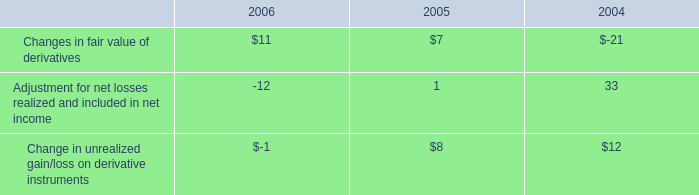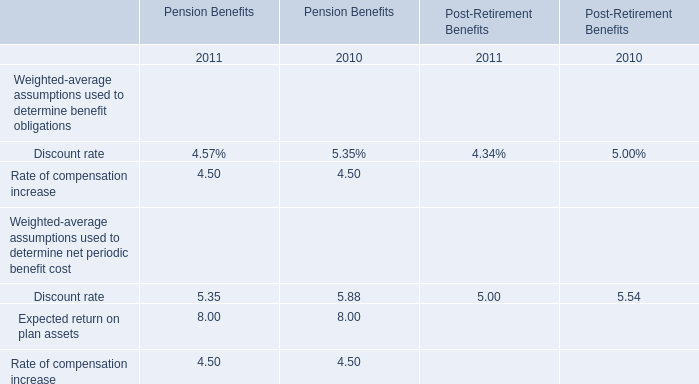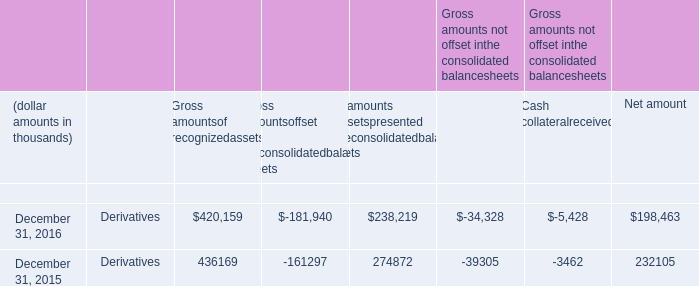What do all Pension Benefits sum up without those Pension Benefits smaller than 5, in 2011? 
Computations: (5.35 + 8.00)
Answer: 13.35. 